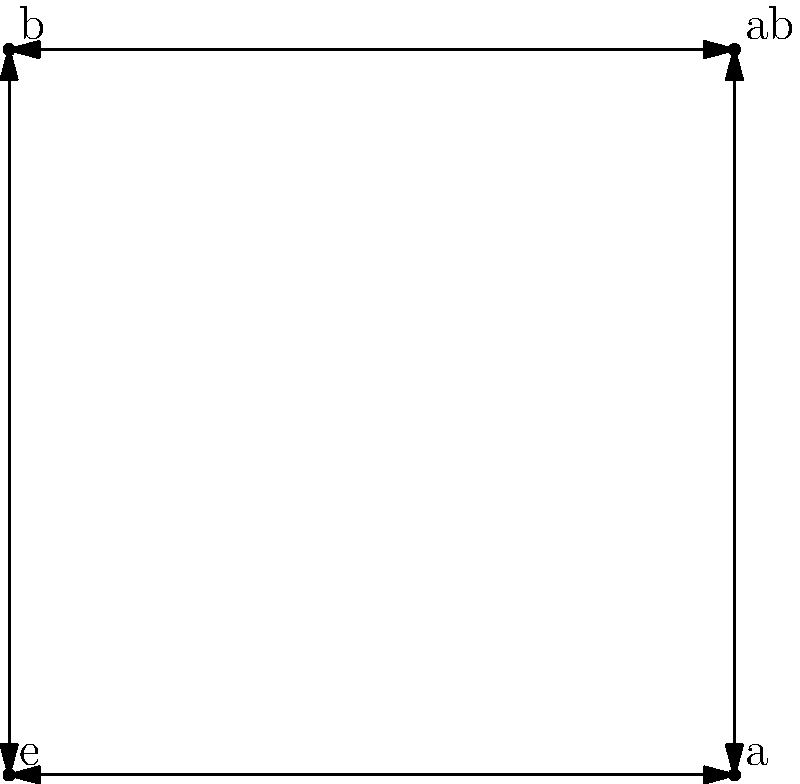Consider the Cayley graph of the Klein four-group $V_4$ shown above. Which of the following statements about this graph is correct?

a) The graph has a directed cycle of length 3.
b) The graph is not vertex-transitive.
c) The graph represents a non-abelian group.
d) The graph has 8 directed edges and 4 vertices. Let's analyze each statement:

1. Directed cycle of length 3:
   The graph doesn't have any directed cycles of length 3. All cycles involve 2 or 4 edges.

2. Vertex-transitivity:
   The graph is vertex-transitive. Each vertex has two incoming and two outgoing edges, making them indistinguishable from a graph-theoretical perspective.

3. Abelian vs. non-abelian:
   The Klein four-group $V_4$ is abelian. This is reflected in the graph by the fact that for any two elements, the order of application doesn't matter. For example, $ab = ba$.

4. Number of edges and vertices:
   The graph clearly has 4 vertices (labeled e, a, b, and ab).
   Counting the edges, we see 8 directed edges (4 pairs of bidirectional edges).

Therefore, the correct statement is option d.

This Cayley graph represents the Klein four-group $V_4 = \{e, a, b, ab\}$ with the following properties:
- $a^2 = b^2 = e$
- $ab = ba$
These properties are reflected in the graph structure.
Answer: d) The graph has 8 directed edges and 4 vertices. 